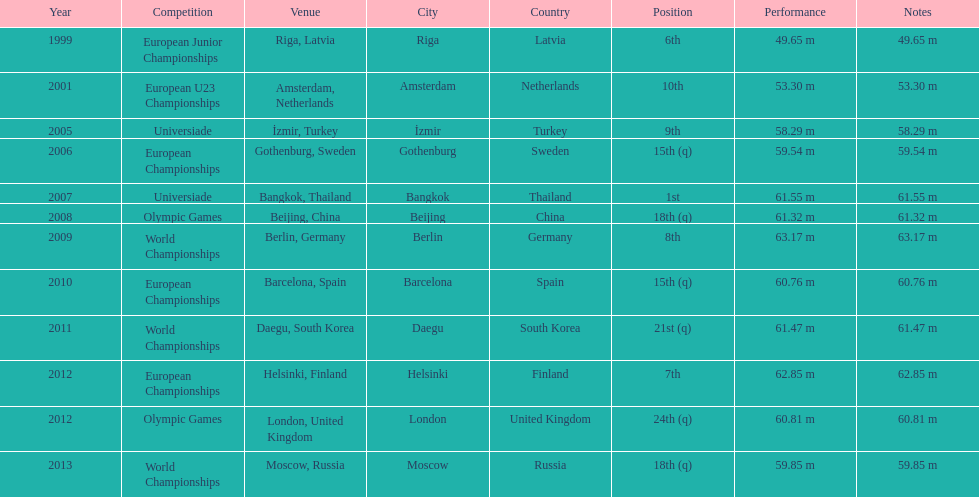Before 2007, what was the top position attained? 6th. 